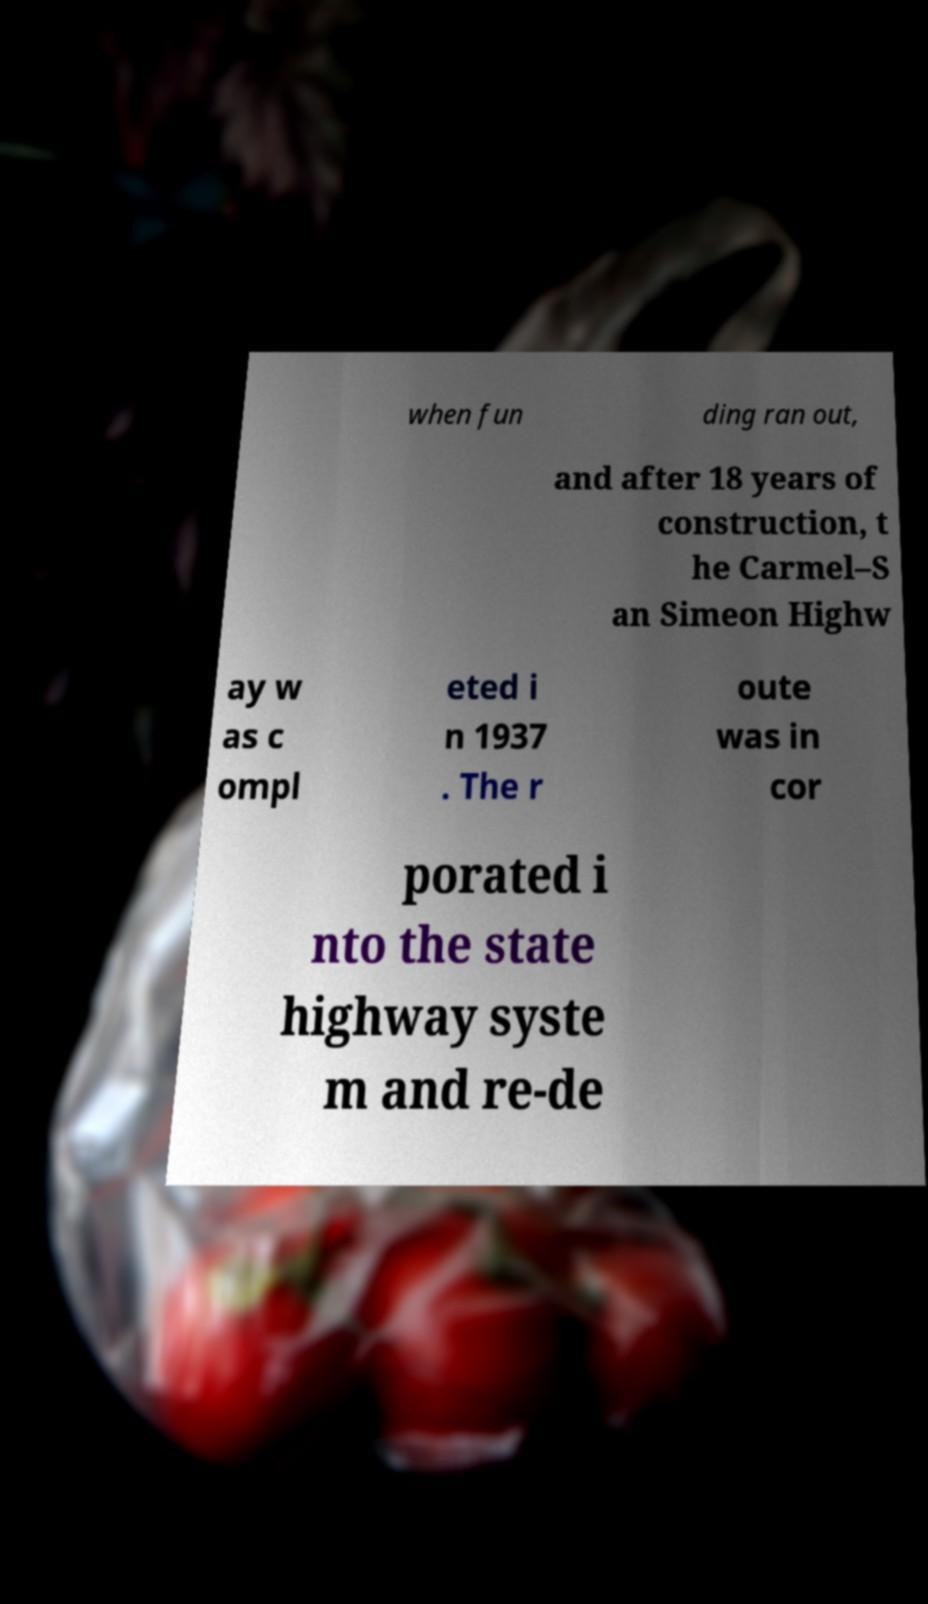Please identify and transcribe the text found in this image. when fun ding ran out, and after 18 years of construction, t he Carmel–S an Simeon Highw ay w as c ompl eted i n 1937 . The r oute was in cor porated i nto the state highway syste m and re-de 